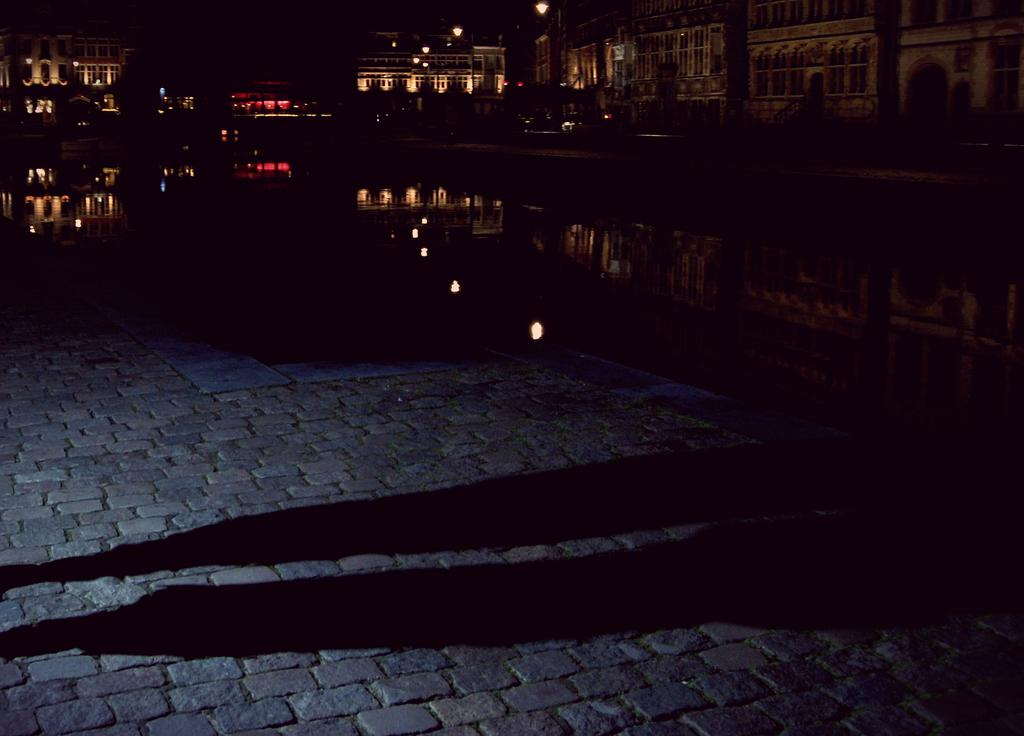What type of structures can be seen in the image? There are buildings in the image. What objects are present to provide illumination at night? There are light poles in the image. What type of vegetation is visible in the image? There are trees in the image. What can be observed due to the presence of light sources in the image? Shadows are visible in the image. How would you describe the overall lighting conditions in the image? The background of the image is dark. What type of game is being played in the image? There is no game being played in the image; it features buildings, light poles, trees, shadows, and a dark background. What is the root of the tree in the image? There is no specific tree mentioned in the image, and even if there were, the root would not be visible in the image. 